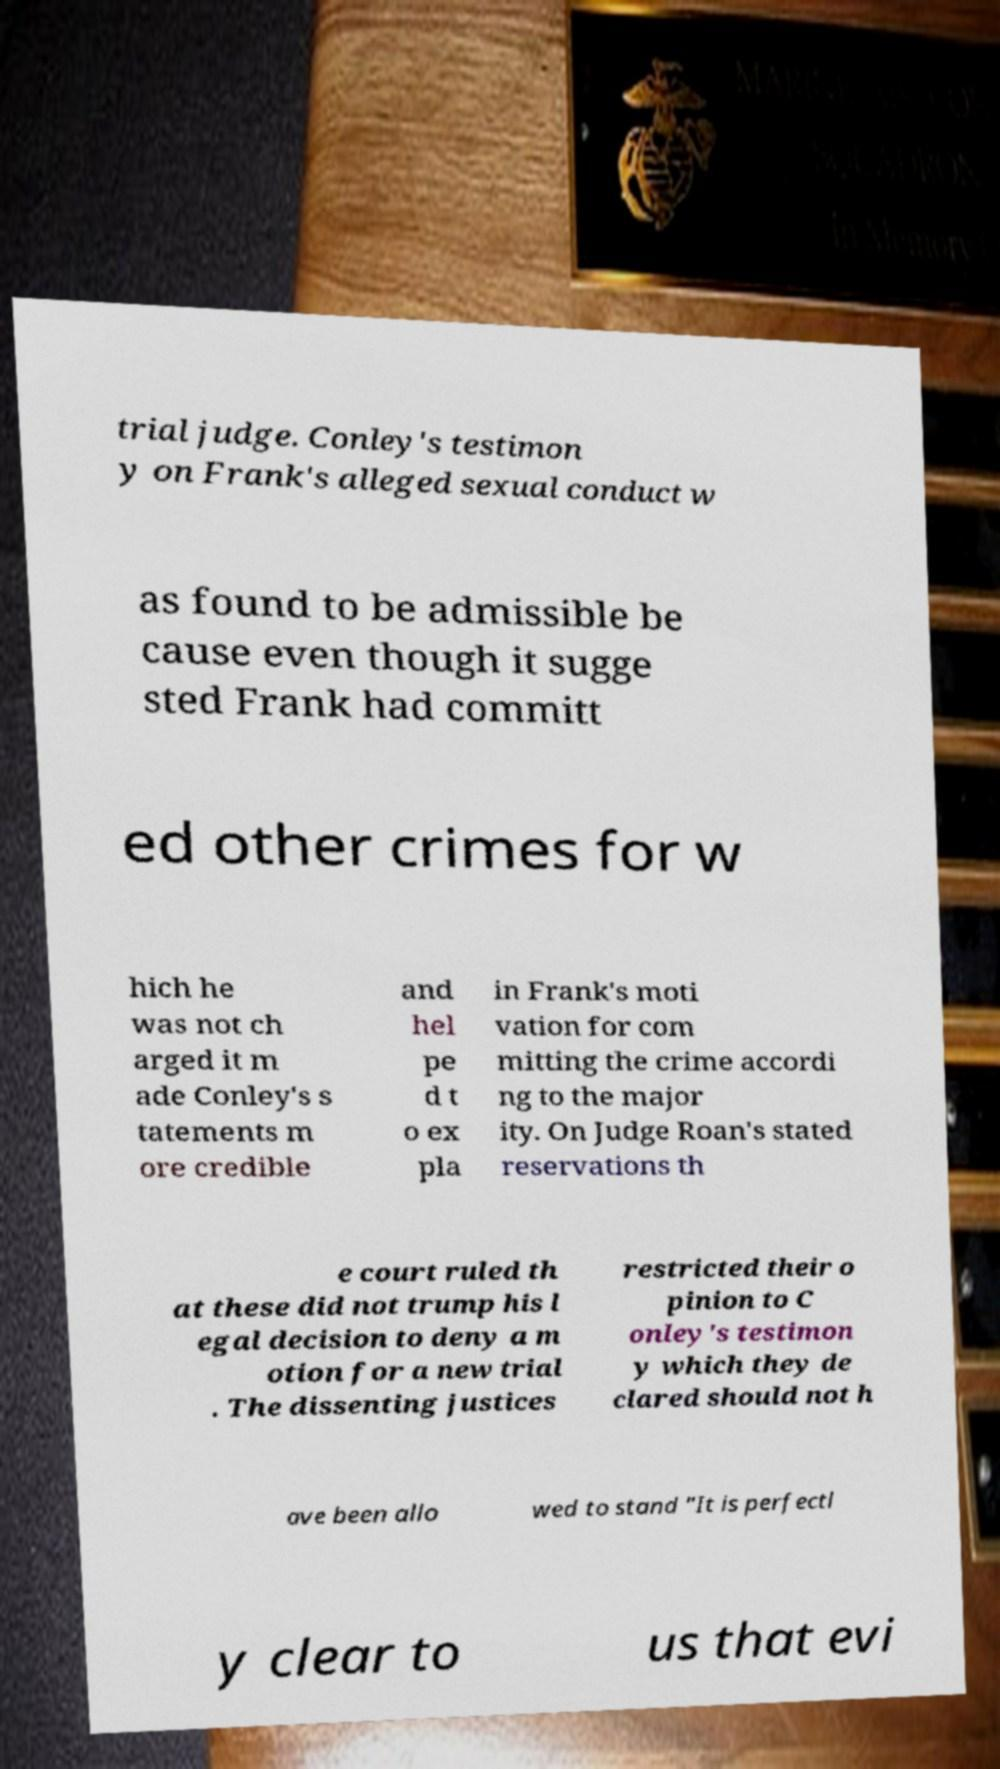Can you accurately transcribe the text from the provided image for me? trial judge. Conley's testimon y on Frank's alleged sexual conduct w as found to be admissible be cause even though it sugge sted Frank had committ ed other crimes for w hich he was not ch arged it m ade Conley's s tatements m ore credible and hel pe d t o ex pla in Frank's moti vation for com mitting the crime accordi ng to the major ity. On Judge Roan's stated reservations th e court ruled th at these did not trump his l egal decision to deny a m otion for a new trial . The dissenting justices restricted their o pinion to C onley's testimon y which they de clared should not h ave been allo wed to stand "It is perfectl y clear to us that evi 